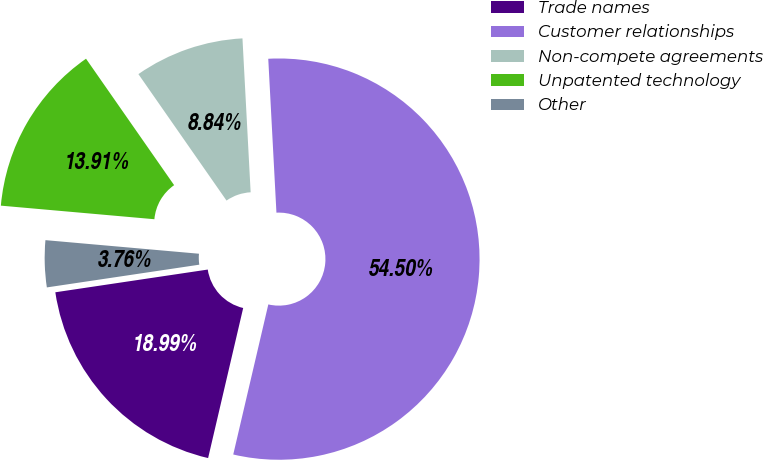<chart> <loc_0><loc_0><loc_500><loc_500><pie_chart><fcel>Trade names<fcel>Customer relationships<fcel>Non-compete agreements<fcel>Unpatented technology<fcel>Other<nl><fcel>18.99%<fcel>54.5%<fcel>8.84%<fcel>13.91%<fcel>3.76%<nl></chart> 